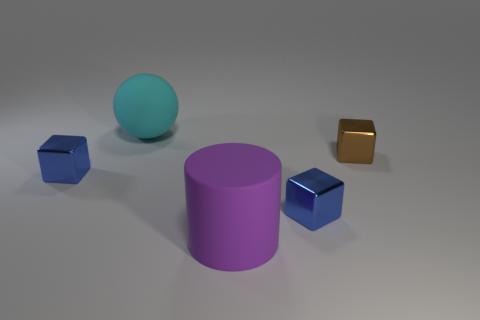What number of objects are either large spheres or shiny blocks right of the large rubber ball?
Offer a terse response. 3. What is the color of the shiny thing that is behind the tiny blue metal block that is left of the cyan thing?
Your answer should be very brief. Brown. How many other objects are the same material as the large cyan object?
Ensure brevity in your answer.  1. What number of rubber objects are large balls or large things?
Keep it short and to the point. 2. What number of things are either cyan cubes or big cyan balls?
Provide a succinct answer. 1. There is a large cyan object that is made of the same material as the big cylinder; what is its shape?
Offer a terse response. Sphere. How many tiny objects are blue shiny objects or cyan balls?
Provide a short and direct response. 2. How many other things are the same color as the rubber ball?
Offer a very short reply. 0. What number of blue metal things are behind the brown cube that is on the right side of the big rubber thing that is behind the small brown shiny block?
Provide a succinct answer. 0. Do the blue object that is on the left side of the cyan matte thing and the small brown object have the same size?
Provide a succinct answer. Yes. 